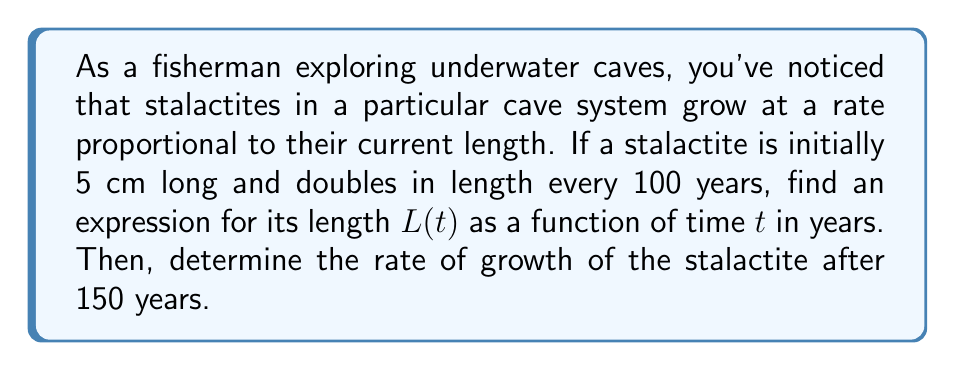Teach me how to tackle this problem. Let's approach this problem step by step using calculus:

1) First, we need to set up a differential equation. The rate of growth is proportional to the current length:

   $$\frac{dL}{dt} = kL$$

   where $k$ is a constant of proportionality.

2) We know that the stalactite doubles in length every 100 years. We can use this to find $k$:

   $$L(100) = 2L(0)$$
   $$5e^{100k} = 2(5)$$
   $$e^{100k} = 2$$
   $$100k = \ln(2)$$
   $$k = \frac{\ln(2)}{100}$$

3) Now we can solve the differential equation:

   $$\frac{dL}{dt} = \frac{\ln(2)}{100}L$$
   $$\int \frac{dL}{L} = \int \frac{\ln(2)}{100}dt$$
   $$\ln(L) = \frac{\ln(2)}{100}t + C$$

4) Using the initial condition $L(0) = 5$:

   $$\ln(5) = C$$

5) Therefore, the general solution is:

   $$\ln(L) = \frac{\ln(2)}{100}t + \ln(5)$$
   $$L(t) = 5e^{\frac{\ln(2)}{100}t}$$

6) To find the rate of growth after 150 years, we need to evaluate $\frac{dL}{dt}$ at $t = 150$:

   $$\frac{dL}{dt} = 5\frac{\ln(2)}{100}e^{\frac{\ln(2)}{100}t}$$

   At $t = 150$:

   $$\frac{dL}{dt}(150) = 5\frac{\ln(2)}{100}e^{\frac{\ln(2)}{100}(150)}$$
   $$= 5\frac{\ln(2)}{100}(2^{1.5})$$
   $$\approx 0.0866 \text{ cm/year}$$
Answer: The length of the stalactite as a function of time is $L(t) = 5e^{\frac{\ln(2)}{100}t}$ cm, where $t$ is in years. The rate of growth after 150 years is approximately 0.0866 cm/year. 